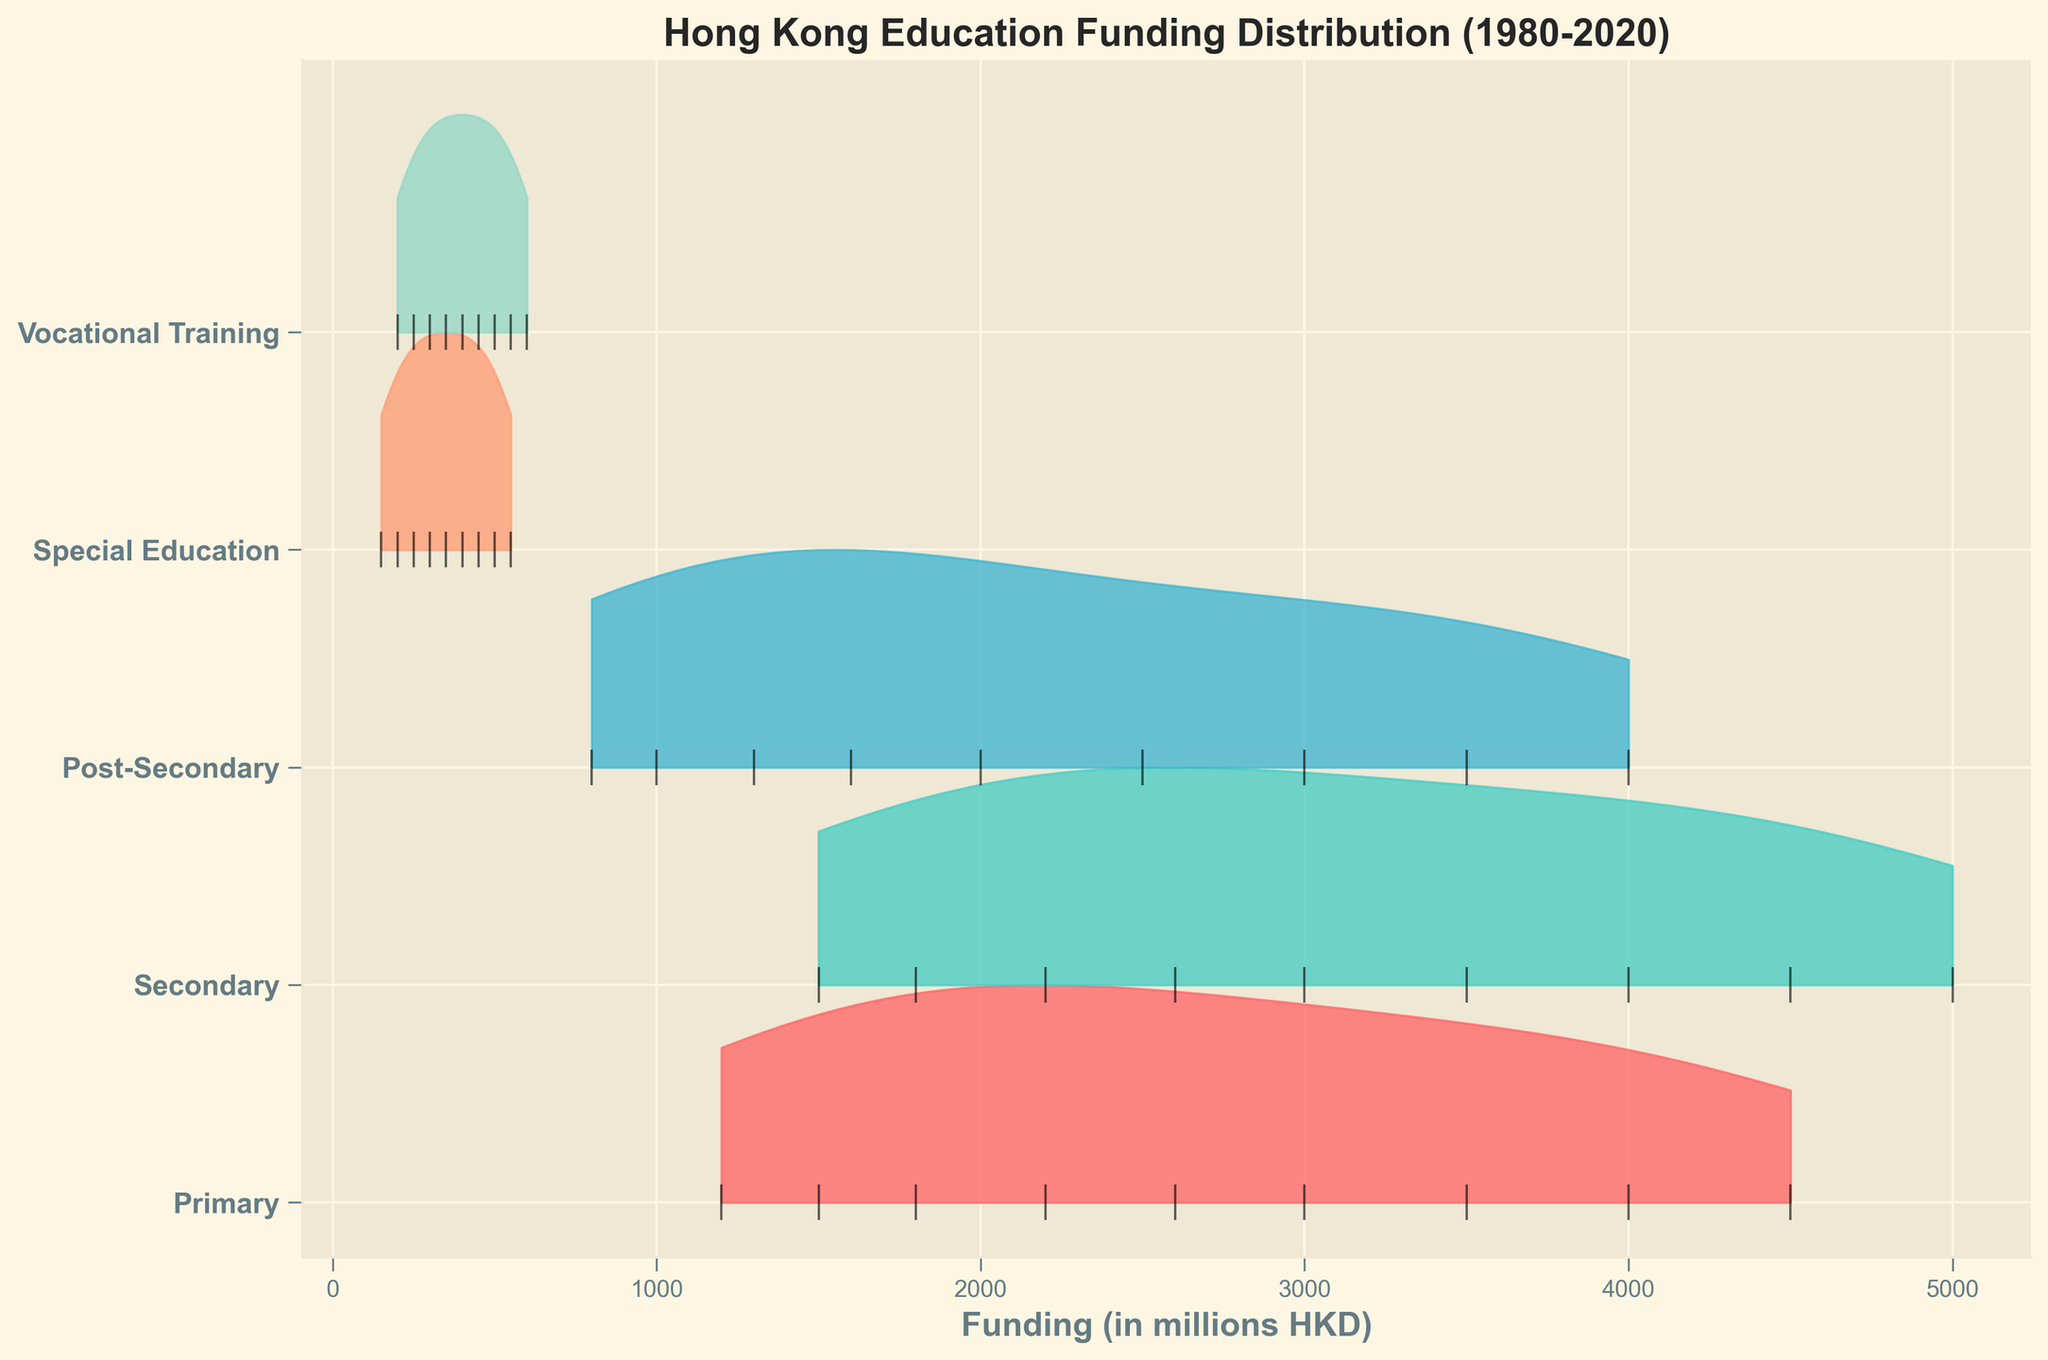what is the title of the ridgeline plot? The title is usually displayed at the top of the plot. In this case, the title is "Hong Kong Education Funding Distribution (1980-2020)."
Answer: Hong Kong Education Funding Distribution (1980-2020) What is the range of funding for the Secondary sector? By observing the horizontal axis corresponding to the Secondary sector's ridgeline, we can see that the funding ranges from around 1500 million HKD in 1980 to 5000 million HKD in 2020.
Answer: 1500 to 5000 million HKD Which educational sector shows the highest funding allocation in 2020? By checking the year 2020 on the plot, and observing the peaks, we see that the Secondary sector has the highest funding allocation in 2020.
Answer: Secondary How does the funding for Vocational Training in 2000 compare to that in 2010? We can compare the heights of the ridgelines at the corresponding years for Vocational Training. In 2000, it is at 400 million HKD, and in 2010, it is 500 million HKD. So, the funding increased.
Answer: Increased from 400 to 500 million HKD What color is used to represent Special Education? We need to identify the ridgeline for Special Education and see its color. The ridgeline for Special Education is in a light red color.
Answer: Light red What does the black vertical line represent on each ridgeline? The black vertical lines indicate the specific years' data points for each sector. Each line corresponds to different years within the plot from 1980 to 2020.
Answer: Specific data points for years How does the funding trend for Primary education change from 1980 to 2020? By following the Primary education ridgeline, we can see that funding consistently increases from 1200 million HKD in 1980 to 4500 million HKD in 2020.
Answer: Consistent increase Which sectors show a funding increase in every decade from 1980 to 2020? By checking the ridgelines for each sector decade by decade, we see that Primary, Secondary, Post-Secondary, Special Education, and Vocational Training all show a funding increase consistently through every decade.
Answer: Primary, Secondary, Post-Secondary, Special Education, Vocational Training Compare the funding allocations for Primary and Post-Secondary education in 1990. What differences can you observe? In the ridgeline plot for the year 1990, the Primary sector is at 1800 million HKD while the Post-Secondary is at 1300 million HKD. So, the Primary sector's funding was 500 million HKD higher than Post-Secondary in that year.
Answer: Primary had 500 million HKD more than Post-Secondary Which sector has the smallest number of funding changes across the years shown? By observing the variability in the ridgelines, Special Education shows the smallest number of funding changes, with the changes being quite gradual compared to other sectors.
Answer: Special Education 